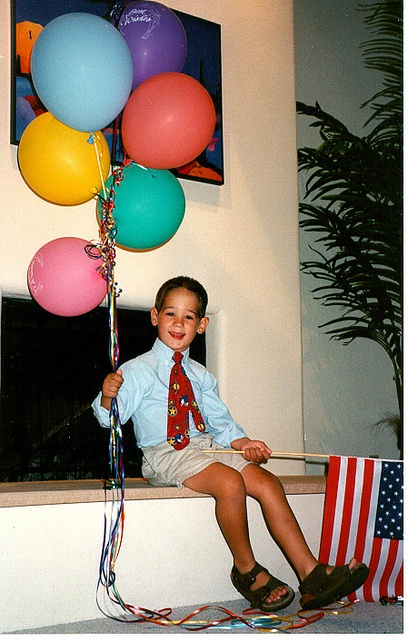Describe the objects in this image and their specific colors. I can see people in tan, black, brown, lightblue, and lightgray tones and tie in tan, maroon, black, and gray tones in this image. 